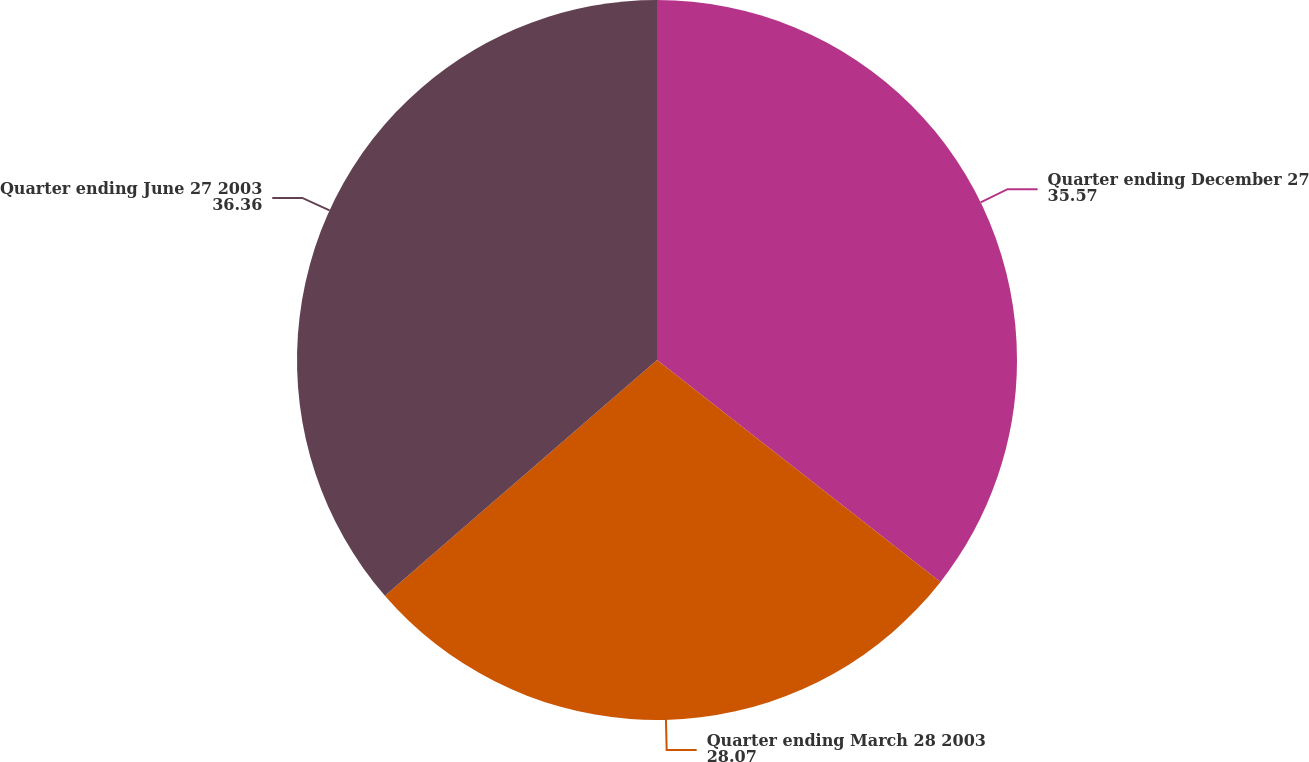<chart> <loc_0><loc_0><loc_500><loc_500><pie_chart><fcel>Quarter ending December 27<fcel>Quarter ending March 28 2003<fcel>Quarter ending June 27 2003<nl><fcel>35.57%<fcel>28.07%<fcel>36.36%<nl></chart> 